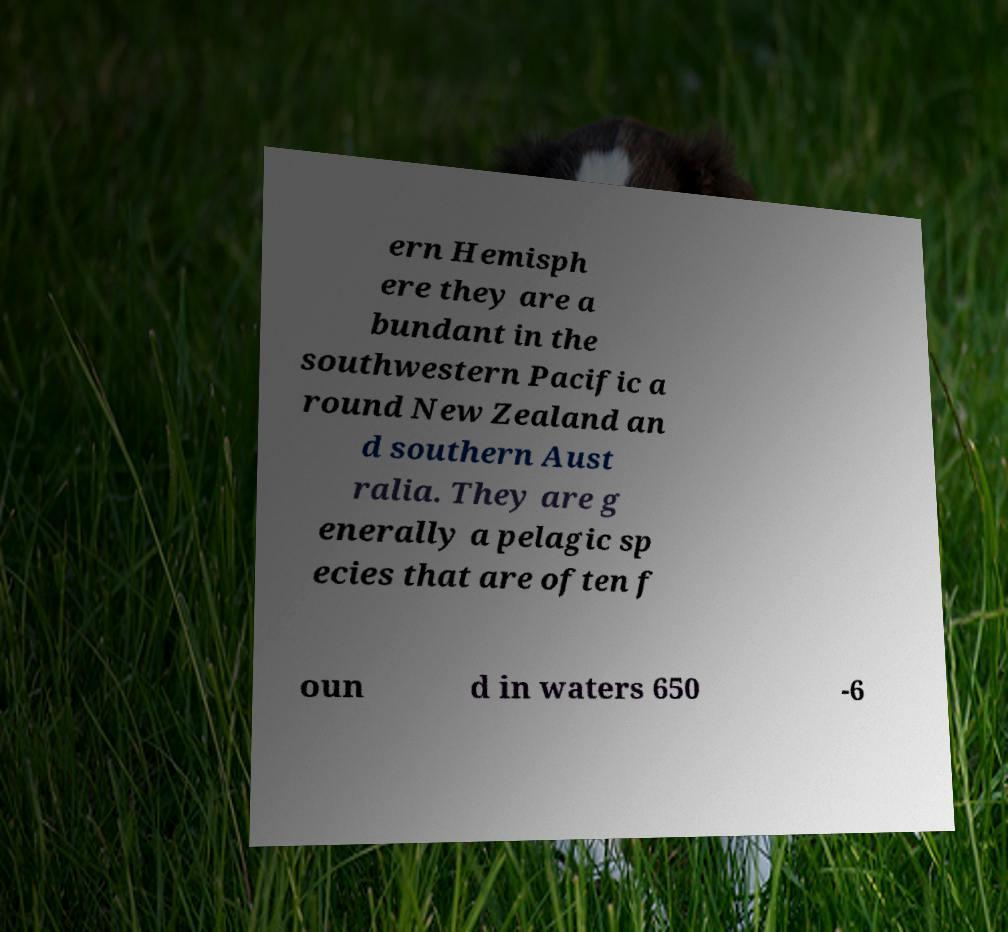Can you read and provide the text displayed in the image?This photo seems to have some interesting text. Can you extract and type it out for me? ern Hemisph ere they are a bundant in the southwestern Pacific a round New Zealand an d southern Aust ralia. They are g enerally a pelagic sp ecies that are often f oun d in waters 650 -6 